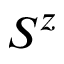<formula> <loc_0><loc_0><loc_500><loc_500>S ^ { z }</formula> 